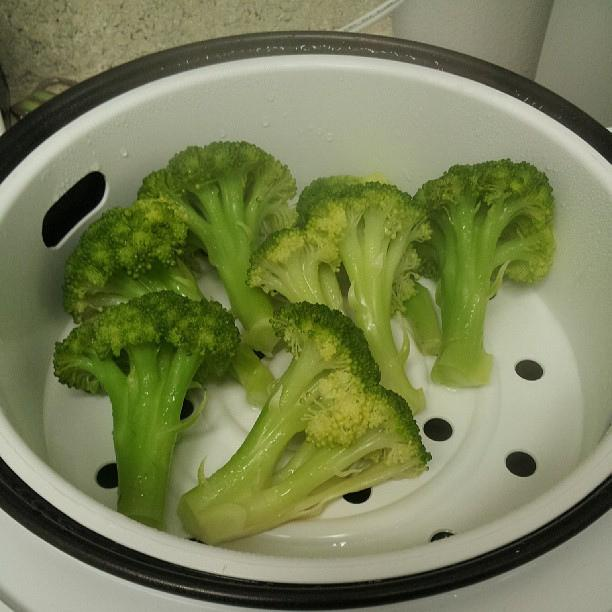What is the method being used to cook the broccoli?

Choices:
A) bake
B) steam
C) fry
D) grill steam 